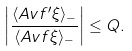<formula> <loc_0><loc_0><loc_500><loc_500>\left | \frac { \langle { A v } f ^ { \prime } \xi \rangle _ { - } } { \langle { A v } f \xi \rangle _ { - } } \right | \leq Q .</formula> 